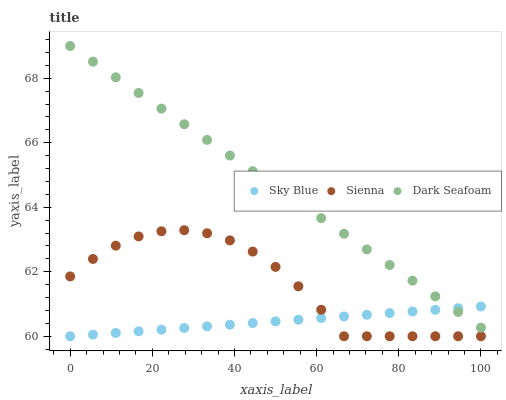Does Sky Blue have the minimum area under the curve?
Answer yes or no. Yes. Does Dark Seafoam have the maximum area under the curve?
Answer yes or no. Yes. Does Dark Seafoam have the minimum area under the curve?
Answer yes or no. No. Does Sky Blue have the maximum area under the curve?
Answer yes or no. No. Is Dark Seafoam the smoothest?
Answer yes or no. Yes. Is Sienna the roughest?
Answer yes or no. Yes. Is Sky Blue the smoothest?
Answer yes or no. No. Is Sky Blue the roughest?
Answer yes or no. No. Does Sienna have the lowest value?
Answer yes or no. Yes. Does Dark Seafoam have the lowest value?
Answer yes or no. No. Does Dark Seafoam have the highest value?
Answer yes or no. Yes. Does Sky Blue have the highest value?
Answer yes or no. No. Is Sienna less than Dark Seafoam?
Answer yes or no. Yes. Is Dark Seafoam greater than Sienna?
Answer yes or no. Yes. Does Dark Seafoam intersect Sky Blue?
Answer yes or no. Yes. Is Dark Seafoam less than Sky Blue?
Answer yes or no. No. Is Dark Seafoam greater than Sky Blue?
Answer yes or no. No. Does Sienna intersect Dark Seafoam?
Answer yes or no. No. 